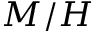<formula> <loc_0><loc_0><loc_500><loc_500>M / H</formula> 